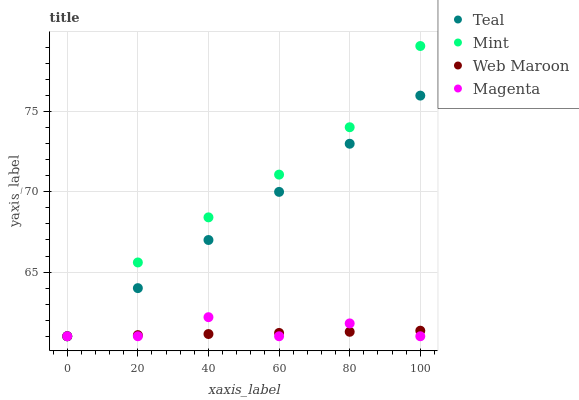Does Web Maroon have the minimum area under the curve?
Answer yes or no. Yes. Does Mint have the maximum area under the curve?
Answer yes or no. Yes. Does Magenta have the minimum area under the curve?
Answer yes or no. No. Does Magenta have the maximum area under the curve?
Answer yes or no. No. Is Teal the smoothest?
Answer yes or no. Yes. Is Magenta the roughest?
Answer yes or no. Yes. Is Mint the smoothest?
Answer yes or no. No. Is Mint the roughest?
Answer yes or no. No. Does Web Maroon have the lowest value?
Answer yes or no. Yes. Does Mint have the highest value?
Answer yes or no. Yes. Does Magenta have the highest value?
Answer yes or no. No. Does Mint intersect Web Maroon?
Answer yes or no. Yes. Is Mint less than Web Maroon?
Answer yes or no. No. Is Mint greater than Web Maroon?
Answer yes or no. No. 